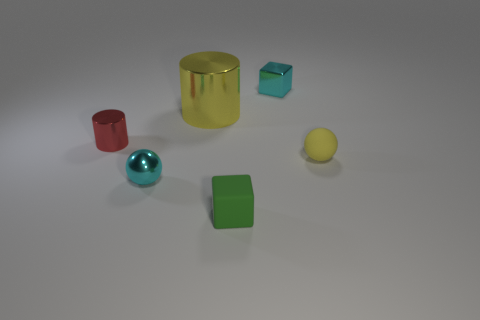There is a cyan object that is left of the matte object that is on the left side of the yellow matte object; what is its material?
Provide a short and direct response. Metal. Do the cyan thing that is to the right of the big thing and the cyan metal thing to the left of the cyan metallic cube have the same shape?
Your answer should be compact. No. Are there the same number of metallic cylinders that are in front of the red shiny cylinder and blue metallic blocks?
Your answer should be compact. Yes. Are there any things behind the small cyan thing that is on the right side of the small green thing?
Provide a succinct answer. No. Is there anything else that is the same color as the tiny metallic cube?
Make the answer very short. Yes. Does the ball to the right of the small shiny cube have the same material as the tiny cyan sphere?
Your answer should be compact. No. Are there an equal number of small red things behind the yellow matte sphere and red metal cylinders in front of the tiny cylinder?
Provide a succinct answer. No. There is a rubber object that is left of the tiny metallic thing that is behind the small red object; what size is it?
Your response must be concise. Small. There is a thing that is both behind the matte sphere and in front of the big metal object; what is its material?
Offer a very short reply. Metal. What number of other objects are there of the same size as the matte cube?
Your answer should be very brief. 4. 